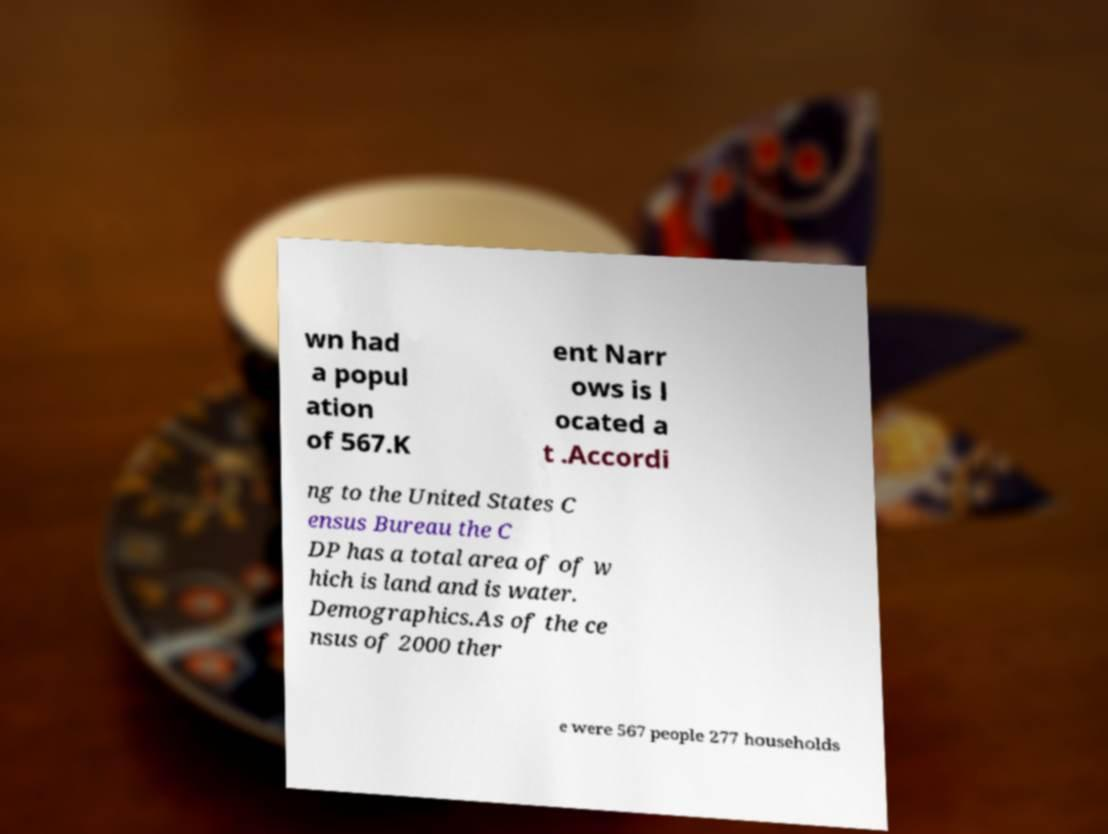I need the written content from this picture converted into text. Can you do that? wn had a popul ation of 567.K ent Narr ows is l ocated a t .Accordi ng to the United States C ensus Bureau the C DP has a total area of of w hich is land and is water. Demographics.As of the ce nsus of 2000 ther e were 567 people 277 households 